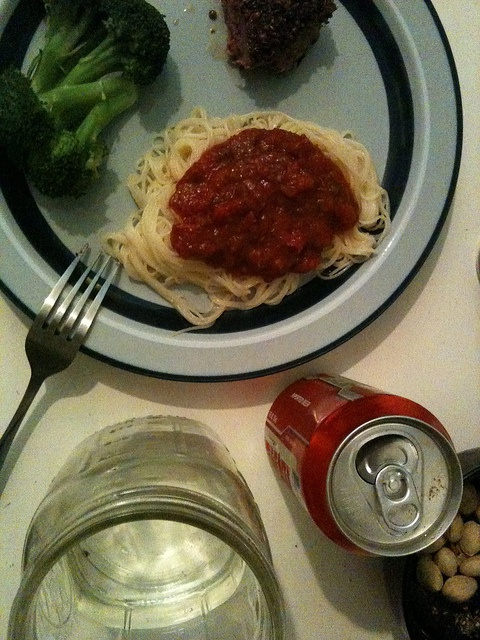Describe the objects in this image and their specific colors. I can see cup in darkgray, olive, darkgreen, and beige tones, broccoli in darkgray, black, and darkgreen tones, broccoli in darkgray, black, and darkgreen tones, and fork in darkgray, black, gray, and darkgreen tones in this image. 